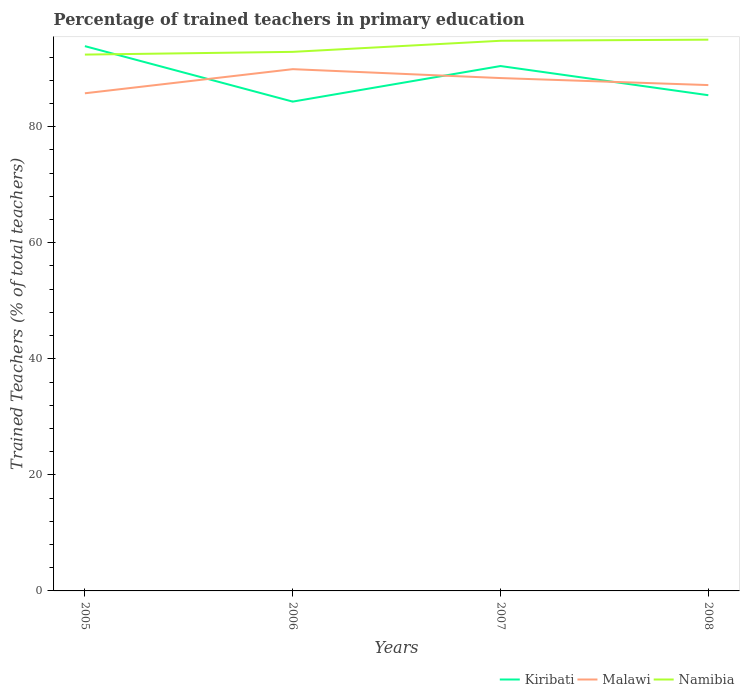How many different coloured lines are there?
Your response must be concise. 3. Is the number of lines equal to the number of legend labels?
Provide a short and direct response. Yes. Across all years, what is the maximum percentage of trained teachers in Namibia?
Provide a short and direct response. 92.43. What is the total percentage of trained teachers in Namibia in the graph?
Your answer should be very brief. -2.57. What is the difference between the highest and the second highest percentage of trained teachers in Malawi?
Provide a short and direct response. 4.16. What is the difference between the highest and the lowest percentage of trained teachers in Namibia?
Your answer should be compact. 2. Is the percentage of trained teachers in Namibia strictly greater than the percentage of trained teachers in Malawi over the years?
Offer a very short reply. No. How many years are there in the graph?
Your answer should be very brief. 4. Does the graph contain any zero values?
Provide a short and direct response. No. Does the graph contain grids?
Your response must be concise. No. How many legend labels are there?
Your response must be concise. 3. What is the title of the graph?
Make the answer very short. Percentage of trained teachers in primary education. What is the label or title of the Y-axis?
Ensure brevity in your answer.  Trained Teachers (% of total teachers). What is the Trained Teachers (% of total teachers) in Kiribati in 2005?
Provide a short and direct response. 93.88. What is the Trained Teachers (% of total teachers) of Malawi in 2005?
Provide a short and direct response. 85.76. What is the Trained Teachers (% of total teachers) in Namibia in 2005?
Offer a terse response. 92.43. What is the Trained Teachers (% of total teachers) in Kiribati in 2006?
Keep it short and to the point. 84.32. What is the Trained Teachers (% of total teachers) of Malawi in 2006?
Provide a succinct answer. 89.92. What is the Trained Teachers (% of total teachers) in Namibia in 2006?
Your answer should be very brief. 92.9. What is the Trained Teachers (% of total teachers) of Kiribati in 2007?
Your answer should be very brief. 90.45. What is the Trained Teachers (% of total teachers) in Malawi in 2007?
Your answer should be very brief. 88.38. What is the Trained Teachers (% of total teachers) of Namibia in 2007?
Give a very brief answer. 94.81. What is the Trained Teachers (% of total teachers) in Kiribati in 2008?
Provide a succinct answer. 85.43. What is the Trained Teachers (% of total teachers) of Malawi in 2008?
Make the answer very short. 87.17. What is the Trained Teachers (% of total teachers) in Namibia in 2008?
Your answer should be compact. 95. Across all years, what is the maximum Trained Teachers (% of total teachers) in Kiribati?
Your answer should be very brief. 93.88. Across all years, what is the maximum Trained Teachers (% of total teachers) of Malawi?
Ensure brevity in your answer.  89.92. Across all years, what is the maximum Trained Teachers (% of total teachers) in Namibia?
Your answer should be compact. 95. Across all years, what is the minimum Trained Teachers (% of total teachers) of Kiribati?
Offer a very short reply. 84.32. Across all years, what is the minimum Trained Teachers (% of total teachers) of Malawi?
Make the answer very short. 85.76. Across all years, what is the minimum Trained Teachers (% of total teachers) of Namibia?
Make the answer very short. 92.43. What is the total Trained Teachers (% of total teachers) of Kiribati in the graph?
Provide a short and direct response. 354.09. What is the total Trained Teachers (% of total teachers) in Malawi in the graph?
Offer a terse response. 351.23. What is the total Trained Teachers (% of total teachers) of Namibia in the graph?
Ensure brevity in your answer.  375.13. What is the difference between the Trained Teachers (% of total teachers) in Kiribati in 2005 and that in 2006?
Make the answer very short. 9.56. What is the difference between the Trained Teachers (% of total teachers) of Malawi in 2005 and that in 2006?
Your response must be concise. -4.16. What is the difference between the Trained Teachers (% of total teachers) of Namibia in 2005 and that in 2006?
Your answer should be very brief. -0.47. What is the difference between the Trained Teachers (% of total teachers) of Kiribati in 2005 and that in 2007?
Offer a terse response. 3.43. What is the difference between the Trained Teachers (% of total teachers) of Malawi in 2005 and that in 2007?
Ensure brevity in your answer.  -2.62. What is the difference between the Trained Teachers (% of total teachers) in Namibia in 2005 and that in 2007?
Make the answer very short. -2.38. What is the difference between the Trained Teachers (% of total teachers) of Kiribati in 2005 and that in 2008?
Your answer should be compact. 8.46. What is the difference between the Trained Teachers (% of total teachers) of Malawi in 2005 and that in 2008?
Give a very brief answer. -1.41. What is the difference between the Trained Teachers (% of total teachers) of Namibia in 2005 and that in 2008?
Give a very brief answer. -2.57. What is the difference between the Trained Teachers (% of total teachers) in Kiribati in 2006 and that in 2007?
Provide a short and direct response. -6.13. What is the difference between the Trained Teachers (% of total teachers) in Malawi in 2006 and that in 2007?
Give a very brief answer. 1.53. What is the difference between the Trained Teachers (% of total teachers) in Namibia in 2006 and that in 2007?
Provide a succinct answer. -1.91. What is the difference between the Trained Teachers (% of total teachers) in Kiribati in 2006 and that in 2008?
Keep it short and to the point. -1.1. What is the difference between the Trained Teachers (% of total teachers) in Malawi in 2006 and that in 2008?
Offer a very short reply. 2.74. What is the difference between the Trained Teachers (% of total teachers) in Namibia in 2006 and that in 2008?
Your answer should be very brief. -2.1. What is the difference between the Trained Teachers (% of total teachers) in Kiribati in 2007 and that in 2008?
Your response must be concise. 5.03. What is the difference between the Trained Teachers (% of total teachers) of Malawi in 2007 and that in 2008?
Provide a short and direct response. 1.21. What is the difference between the Trained Teachers (% of total teachers) in Namibia in 2007 and that in 2008?
Ensure brevity in your answer.  -0.19. What is the difference between the Trained Teachers (% of total teachers) in Kiribati in 2005 and the Trained Teachers (% of total teachers) in Malawi in 2006?
Your answer should be very brief. 3.97. What is the difference between the Trained Teachers (% of total teachers) of Kiribati in 2005 and the Trained Teachers (% of total teachers) of Namibia in 2006?
Offer a terse response. 0.99. What is the difference between the Trained Teachers (% of total teachers) of Malawi in 2005 and the Trained Teachers (% of total teachers) of Namibia in 2006?
Ensure brevity in your answer.  -7.14. What is the difference between the Trained Teachers (% of total teachers) of Kiribati in 2005 and the Trained Teachers (% of total teachers) of Malawi in 2007?
Keep it short and to the point. 5.5. What is the difference between the Trained Teachers (% of total teachers) in Kiribati in 2005 and the Trained Teachers (% of total teachers) in Namibia in 2007?
Provide a short and direct response. -0.92. What is the difference between the Trained Teachers (% of total teachers) of Malawi in 2005 and the Trained Teachers (% of total teachers) of Namibia in 2007?
Make the answer very short. -9.05. What is the difference between the Trained Teachers (% of total teachers) of Kiribati in 2005 and the Trained Teachers (% of total teachers) of Malawi in 2008?
Keep it short and to the point. 6.71. What is the difference between the Trained Teachers (% of total teachers) of Kiribati in 2005 and the Trained Teachers (% of total teachers) of Namibia in 2008?
Your response must be concise. -1.11. What is the difference between the Trained Teachers (% of total teachers) of Malawi in 2005 and the Trained Teachers (% of total teachers) of Namibia in 2008?
Your answer should be compact. -9.24. What is the difference between the Trained Teachers (% of total teachers) in Kiribati in 2006 and the Trained Teachers (% of total teachers) in Malawi in 2007?
Provide a succinct answer. -4.06. What is the difference between the Trained Teachers (% of total teachers) of Kiribati in 2006 and the Trained Teachers (% of total teachers) of Namibia in 2007?
Your answer should be very brief. -10.48. What is the difference between the Trained Teachers (% of total teachers) of Malawi in 2006 and the Trained Teachers (% of total teachers) of Namibia in 2007?
Your answer should be compact. -4.89. What is the difference between the Trained Teachers (% of total teachers) in Kiribati in 2006 and the Trained Teachers (% of total teachers) in Malawi in 2008?
Provide a short and direct response. -2.85. What is the difference between the Trained Teachers (% of total teachers) of Kiribati in 2006 and the Trained Teachers (% of total teachers) of Namibia in 2008?
Ensure brevity in your answer.  -10.67. What is the difference between the Trained Teachers (% of total teachers) in Malawi in 2006 and the Trained Teachers (% of total teachers) in Namibia in 2008?
Provide a succinct answer. -5.08. What is the difference between the Trained Teachers (% of total teachers) of Kiribati in 2007 and the Trained Teachers (% of total teachers) of Malawi in 2008?
Offer a terse response. 3.28. What is the difference between the Trained Teachers (% of total teachers) in Kiribati in 2007 and the Trained Teachers (% of total teachers) in Namibia in 2008?
Make the answer very short. -4.54. What is the difference between the Trained Teachers (% of total teachers) in Malawi in 2007 and the Trained Teachers (% of total teachers) in Namibia in 2008?
Offer a very short reply. -6.62. What is the average Trained Teachers (% of total teachers) in Kiribati per year?
Your answer should be very brief. 88.52. What is the average Trained Teachers (% of total teachers) of Malawi per year?
Offer a terse response. 87.81. What is the average Trained Teachers (% of total teachers) in Namibia per year?
Provide a short and direct response. 93.78. In the year 2005, what is the difference between the Trained Teachers (% of total teachers) in Kiribati and Trained Teachers (% of total teachers) in Malawi?
Keep it short and to the point. 8.12. In the year 2005, what is the difference between the Trained Teachers (% of total teachers) of Kiribati and Trained Teachers (% of total teachers) of Namibia?
Keep it short and to the point. 1.46. In the year 2005, what is the difference between the Trained Teachers (% of total teachers) in Malawi and Trained Teachers (% of total teachers) in Namibia?
Offer a terse response. -6.67. In the year 2006, what is the difference between the Trained Teachers (% of total teachers) in Kiribati and Trained Teachers (% of total teachers) in Malawi?
Offer a very short reply. -5.59. In the year 2006, what is the difference between the Trained Teachers (% of total teachers) in Kiribati and Trained Teachers (% of total teachers) in Namibia?
Provide a short and direct response. -8.57. In the year 2006, what is the difference between the Trained Teachers (% of total teachers) of Malawi and Trained Teachers (% of total teachers) of Namibia?
Keep it short and to the point. -2.98. In the year 2007, what is the difference between the Trained Teachers (% of total teachers) in Kiribati and Trained Teachers (% of total teachers) in Malawi?
Give a very brief answer. 2.07. In the year 2007, what is the difference between the Trained Teachers (% of total teachers) in Kiribati and Trained Teachers (% of total teachers) in Namibia?
Your answer should be very brief. -4.35. In the year 2007, what is the difference between the Trained Teachers (% of total teachers) of Malawi and Trained Teachers (% of total teachers) of Namibia?
Give a very brief answer. -6.43. In the year 2008, what is the difference between the Trained Teachers (% of total teachers) of Kiribati and Trained Teachers (% of total teachers) of Malawi?
Keep it short and to the point. -1.75. In the year 2008, what is the difference between the Trained Teachers (% of total teachers) in Kiribati and Trained Teachers (% of total teachers) in Namibia?
Keep it short and to the point. -9.57. In the year 2008, what is the difference between the Trained Teachers (% of total teachers) in Malawi and Trained Teachers (% of total teachers) in Namibia?
Provide a succinct answer. -7.83. What is the ratio of the Trained Teachers (% of total teachers) in Kiribati in 2005 to that in 2006?
Ensure brevity in your answer.  1.11. What is the ratio of the Trained Teachers (% of total teachers) of Malawi in 2005 to that in 2006?
Your answer should be compact. 0.95. What is the ratio of the Trained Teachers (% of total teachers) of Namibia in 2005 to that in 2006?
Give a very brief answer. 0.99. What is the ratio of the Trained Teachers (% of total teachers) of Kiribati in 2005 to that in 2007?
Offer a very short reply. 1.04. What is the ratio of the Trained Teachers (% of total teachers) of Malawi in 2005 to that in 2007?
Your answer should be compact. 0.97. What is the ratio of the Trained Teachers (% of total teachers) of Namibia in 2005 to that in 2007?
Provide a short and direct response. 0.97. What is the ratio of the Trained Teachers (% of total teachers) of Kiribati in 2005 to that in 2008?
Offer a terse response. 1.1. What is the ratio of the Trained Teachers (% of total teachers) in Malawi in 2005 to that in 2008?
Make the answer very short. 0.98. What is the ratio of the Trained Teachers (% of total teachers) of Namibia in 2005 to that in 2008?
Ensure brevity in your answer.  0.97. What is the ratio of the Trained Teachers (% of total teachers) in Kiribati in 2006 to that in 2007?
Your answer should be compact. 0.93. What is the ratio of the Trained Teachers (% of total teachers) of Malawi in 2006 to that in 2007?
Keep it short and to the point. 1.02. What is the ratio of the Trained Teachers (% of total teachers) in Namibia in 2006 to that in 2007?
Provide a succinct answer. 0.98. What is the ratio of the Trained Teachers (% of total teachers) in Kiribati in 2006 to that in 2008?
Give a very brief answer. 0.99. What is the ratio of the Trained Teachers (% of total teachers) of Malawi in 2006 to that in 2008?
Keep it short and to the point. 1.03. What is the ratio of the Trained Teachers (% of total teachers) of Namibia in 2006 to that in 2008?
Ensure brevity in your answer.  0.98. What is the ratio of the Trained Teachers (% of total teachers) of Kiribati in 2007 to that in 2008?
Your answer should be compact. 1.06. What is the ratio of the Trained Teachers (% of total teachers) in Malawi in 2007 to that in 2008?
Your answer should be compact. 1.01. What is the difference between the highest and the second highest Trained Teachers (% of total teachers) of Kiribati?
Offer a very short reply. 3.43. What is the difference between the highest and the second highest Trained Teachers (% of total teachers) of Malawi?
Provide a succinct answer. 1.53. What is the difference between the highest and the second highest Trained Teachers (% of total teachers) of Namibia?
Make the answer very short. 0.19. What is the difference between the highest and the lowest Trained Teachers (% of total teachers) in Kiribati?
Make the answer very short. 9.56. What is the difference between the highest and the lowest Trained Teachers (% of total teachers) of Malawi?
Keep it short and to the point. 4.16. What is the difference between the highest and the lowest Trained Teachers (% of total teachers) in Namibia?
Ensure brevity in your answer.  2.57. 